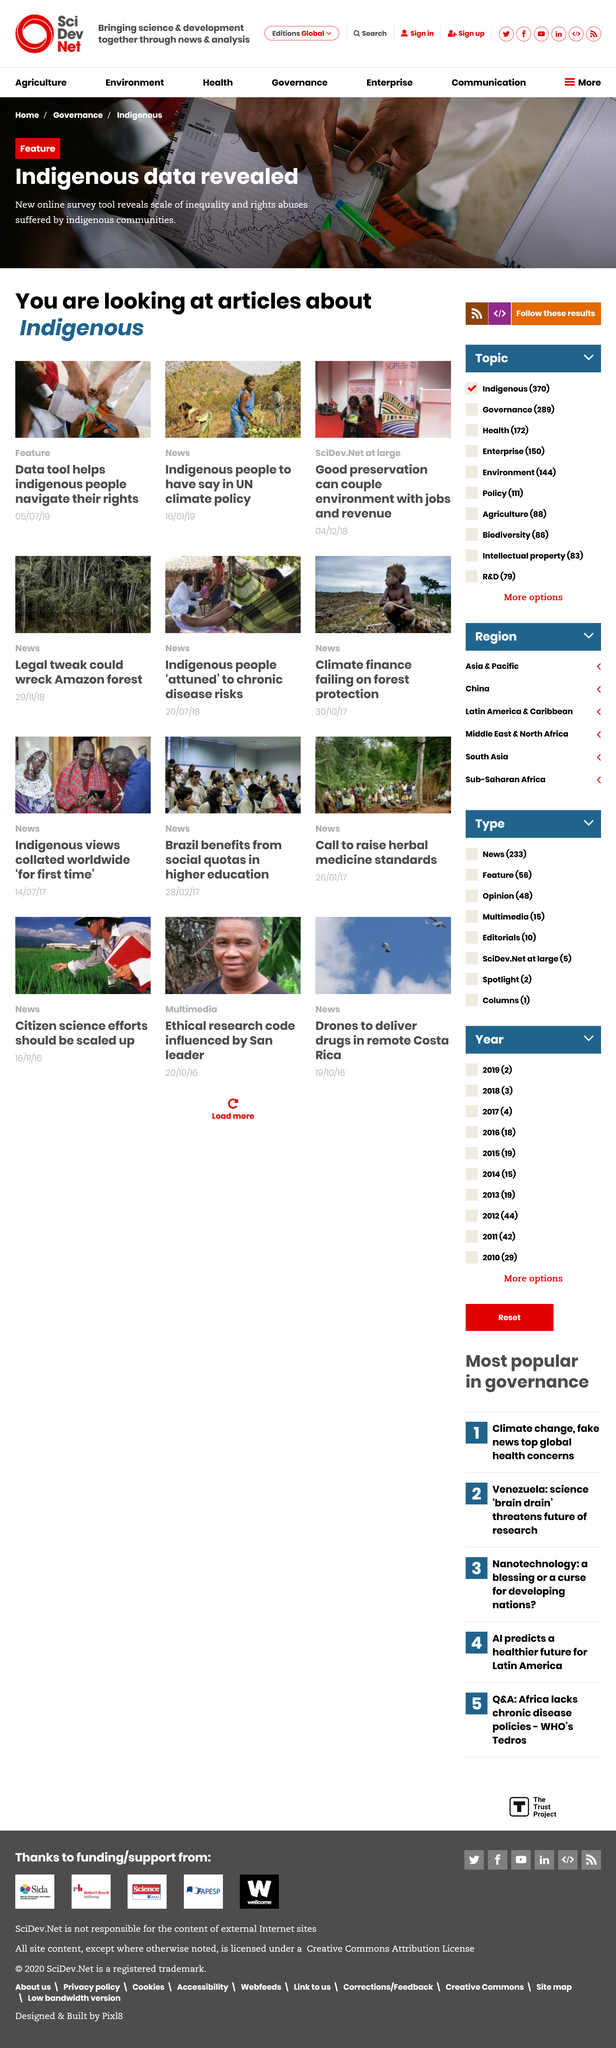Indicate a few pertinent items in this graphic. Good preservation has the ability to effectively combine the environment with employment and revenue opportunities, thereby achieving a positive impact on society. Indigenous data was revealed using new online survey tools. The article on indigenous people having a say in UN climate policy was published on January 16, 2019. 